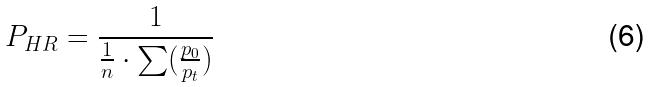<formula> <loc_0><loc_0><loc_500><loc_500>P _ { H R } = \frac { 1 } { \frac { 1 } { n } \cdot \sum ( \frac { p _ { 0 } } { p _ { t } } ) }</formula> 